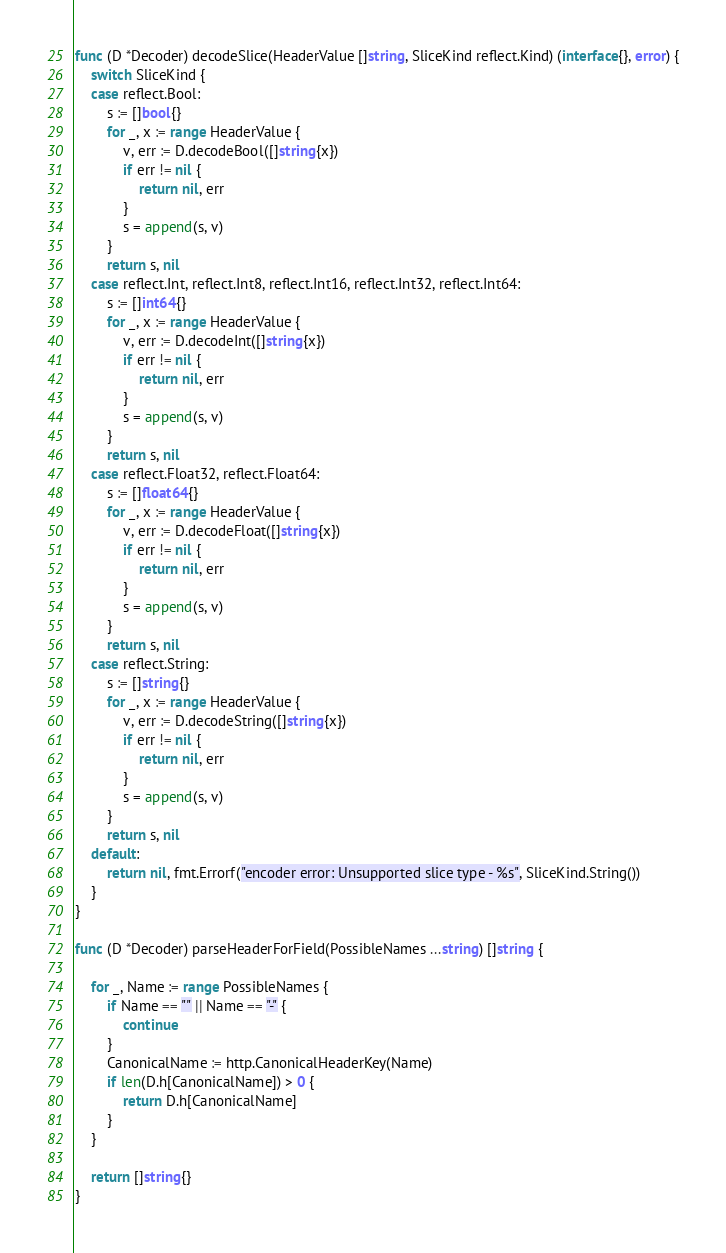Convert code to text. <code><loc_0><loc_0><loc_500><loc_500><_Go_>func (D *Decoder) decodeSlice(HeaderValue []string, SliceKind reflect.Kind) (interface{}, error) {
	switch SliceKind {
	case reflect.Bool:
		s := []bool{}
		for _, x := range HeaderValue {
			v, err := D.decodeBool([]string{x})
			if err != nil {
				return nil, err
			}
			s = append(s, v)
		}
		return s, nil
	case reflect.Int, reflect.Int8, reflect.Int16, reflect.Int32, reflect.Int64:
		s := []int64{}
		for _, x := range HeaderValue {
			v, err := D.decodeInt([]string{x})
			if err != nil {
				return nil, err
			}
			s = append(s, v)
		}
		return s, nil
	case reflect.Float32, reflect.Float64:
		s := []float64{}
		for _, x := range HeaderValue {
			v, err := D.decodeFloat([]string{x})
			if err != nil {
				return nil, err
			}
			s = append(s, v)
		}
		return s, nil
	case reflect.String:
		s := []string{}
		for _, x := range HeaderValue {
			v, err := D.decodeString([]string{x})
			if err != nil {
				return nil, err
			}
			s = append(s, v)
		}
		return s, nil
	default:
		return nil, fmt.Errorf("encoder error: Unsupported slice type - %s", SliceKind.String())
	}
}

func (D *Decoder) parseHeaderForField(PossibleNames ...string) []string {

	for _, Name := range PossibleNames {
		if Name == "" || Name == "-" {
			continue
		}
		CanonicalName := http.CanonicalHeaderKey(Name)
		if len(D.h[CanonicalName]) > 0 {
			return D.h[CanonicalName]
		}
	}

	return []string{}
}
</code> 